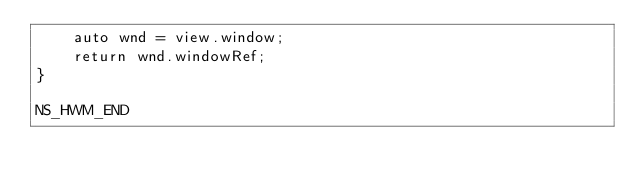<code> <loc_0><loc_0><loc_500><loc_500><_ObjectiveC_>    auto wnd = view.window;
    return wnd.windowRef;
}

NS_HWM_END
</code> 